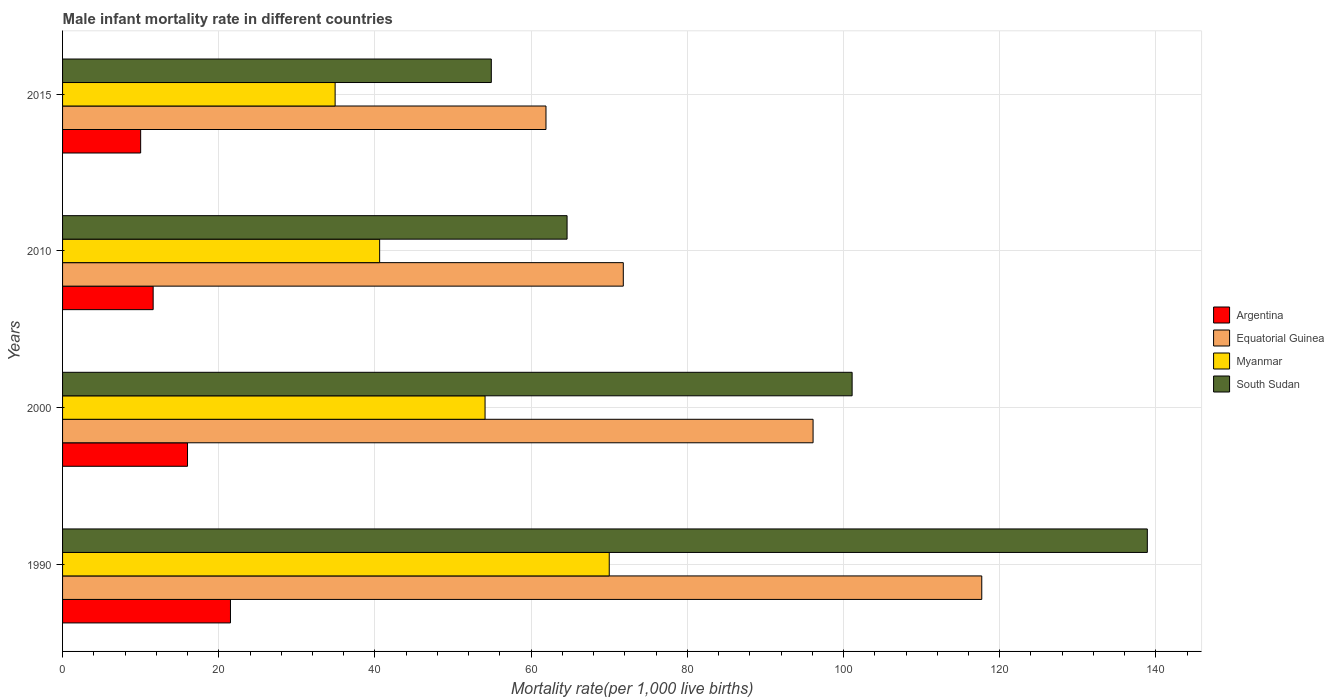Are the number of bars on each tick of the Y-axis equal?
Keep it short and to the point. Yes. What is the label of the 4th group of bars from the top?
Keep it short and to the point. 1990. What is the male infant mortality rate in Argentina in 1990?
Ensure brevity in your answer.  21.5. Across all years, what is the maximum male infant mortality rate in Equatorial Guinea?
Your answer should be very brief. 117.7. Across all years, what is the minimum male infant mortality rate in Argentina?
Provide a short and direct response. 10. In which year was the male infant mortality rate in Argentina maximum?
Provide a short and direct response. 1990. In which year was the male infant mortality rate in South Sudan minimum?
Your answer should be compact. 2015. What is the total male infant mortality rate in Myanmar in the graph?
Make the answer very short. 199.6. What is the difference between the male infant mortality rate in Myanmar in 1990 and that in 2000?
Make the answer very short. 15.9. What is the difference between the male infant mortality rate in Argentina in 2010 and the male infant mortality rate in Equatorial Guinea in 2015?
Ensure brevity in your answer.  -50.3. What is the average male infant mortality rate in Equatorial Guinea per year?
Make the answer very short. 86.88. In the year 2015, what is the difference between the male infant mortality rate in South Sudan and male infant mortality rate in Argentina?
Make the answer very short. 44.9. In how many years, is the male infant mortality rate in South Sudan greater than 100 ?
Your response must be concise. 2. What is the ratio of the male infant mortality rate in South Sudan in 2000 to that in 2015?
Ensure brevity in your answer.  1.84. Is the difference between the male infant mortality rate in South Sudan in 1990 and 2015 greater than the difference between the male infant mortality rate in Argentina in 1990 and 2015?
Offer a terse response. Yes. What is the difference between the highest and the second highest male infant mortality rate in Myanmar?
Make the answer very short. 15.9. Is the sum of the male infant mortality rate in Argentina in 2010 and 2015 greater than the maximum male infant mortality rate in South Sudan across all years?
Offer a very short reply. No. What does the 4th bar from the top in 2015 represents?
Keep it short and to the point. Argentina. Is it the case that in every year, the sum of the male infant mortality rate in South Sudan and male infant mortality rate in Equatorial Guinea is greater than the male infant mortality rate in Argentina?
Your answer should be very brief. Yes. Are the values on the major ticks of X-axis written in scientific E-notation?
Give a very brief answer. No. How many legend labels are there?
Offer a terse response. 4. How are the legend labels stacked?
Your answer should be compact. Vertical. What is the title of the graph?
Offer a very short reply. Male infant mortality rate in different countries. Does "St. Lucia" appear as one of the legend labels in the graph?
Your response must be concise. No. What is the label or title of the X-axis?
Your response must be concise. Mortality rate(per 1,0 live births). What is the label or title of the Y-axis?
Your answer should be compact. Years. What is the Mortality rate(per 1,000 live births) in Equatorial Guinea in 1990?
Keep it short and to the point. 117.7. What is the Mortality rate(per 1,000 live births) of Myanmar in 1990?
Offer a very short reply. 70. What is the Mortality rate(per 1,000 live births) of South Sudan in 1990?
Your response must be concise. 138.9. What is the Mortality rate(per 1,000 live births) in Equatorial Guinea in 2000?
Provide a succinct answer. 96.1. What is the Mortality rate(per 1,000 live births) in Myanmar in 2000?
Provide a succinct answer. 54.1. What is the Mortality rate(per 1,000 live births) of South Sudan in 2000?
Ensure brevity in your answer.  101.1. What is the Mortality rate(per 1,000 live births) of Equatorial Guinea in 2010?
Your answer should be compact. 71.8. What is the Mortality rate(per 1,000 live births) of Myanmar in 2010?
Your answer should be compact. 40.6. What is the Mortality rate(per 1,000 live births) in South Sudan in 2010?
Give a very brief answer. 64.6. What is the Mortality rate(per 1,000 live births) in Equatorial Guinea in 2015?
Make the answer very short. 61.9. What is the Mortality rate(per 1,000 live births) in Myanmar in 2015?
Offer a very short reply. 34.9. What is the Mortality rate(per 1,000 live births) of South Sudan in 2015?
Offer a very short reply. 54.9. Across all years, what is the maximum Mortality rate(per 1,000 live births) of Equatorial Guinea?
Make the answer very short. 117.7. Across all years, what is the maximum Mortality rate(per 1,000 live births) in Myanmar?
Offer a very short reply. 70. Across all years, what is the maximum Mortality rate(per 1,000 live births) of South Sudan?
Offer a terse response. 138.9. Across all years, what is the minimum Mortality rate(per 1,000 live births) of Argentina?
Give a very brief answer. 10. Across all years, what is the minimum Mortality rate(per 1,000 live births) in Equatorial Guinea?
Provide a short and direct response. 61.9. Across all years, what is the minimum Mortality rate(per 1,000 live births) in Myanmar?
Your answer should be compact. 34.9. Across all years, what is the minimum Mortality rate(per 1,000 live births) in South Sudan?
Make the answer very short. 54.9. What is the total Mortality rate(per 1,000 live births) of Argentina in the graph?
Keep it short and to the point. 59.1. What is the total Mortality rate(per 1,000 live births) in Equatorial Guinea in the graph?
Keep it short and to the point. 347.5. What is the total Mortality rate(per 1,000 live births) of Myanmar in the graph?
Your answer should be compact. 199.6. What is the total Mortality rate(per 1,000 live births) of South Sudan in the graph?
Ensure brevity in your answer.  359.5. What is the difference between the Mortality rate(per 1,000 live births) in Equatorial Guinea in 1990 and that in 2000?
Your answer should be compact. 21.6. What is the difference between the Mortality rate(per 1,000 live births) in South Sudan in 1990 and that in 2000?
Offer a terse response. 37.8. What is the difference between the Mortality rate(per 1,000 live births) in Argentina in 1990 and that in 2010?
Give a very brief answer. 9.9. What is the difference between the Mortality rate(per 1,000 live births) of Equatorial Guinea in 1990 and that in 2010?
Make the answer very short. 45.9. What is the difference between the Mortality rate(per 1,000 live births) in Myanmar in 1990 and that in 2010?
Make the answer very short. 29.4. What is the difference between the Mortality rate(per 1,000 live births) in South Sudan in 1990 and that in 2010?
Give a very brief answer. 74.3. What is the difference between the Mortality rate(per 1,000 live births) in Argentina in 1990 and that in 2015?
Your response must be concise. 11.5. What is the difference between the Mortality rate(per 1,000 live births) of Equatorial Guinea in 1990 and that in 2015?
Give a very brief answer. 55.8. What is the difference between the Mortality rate(per 1,000 live births) of Myanmar in 1990 and that in 2015?
Give a very brief answer. 35.1. What is the difference between the Mortality rate(per 1,000 live births) in Argentina in 2000 and that in 2010?
Your answer should be very brief. 4.4. What is the difference between the Mortality rate(per 1,000 live births) in Equatorial Guinea in 2000 and that in 2010?
Your answer should be very brief. 24.3. What is the difference between the Mortality rate(per 1,000 live births) in Myanmar in 2000 and that in 2010?
Give a very brief answer. 13.5. What is the difference between the Mortality rate(per 1,000 live births) in South Sudan in 2000 and that in 2010?
Ensure brevity in your answer.  36.5. What is the difference between the Mortality rate(per 1,000 live births) in Argentina in 2000 and that in 2015?
Offer a terse response. 6. What is the difference between the Mortality rate(per 1,000 live births) in Equatorial Guinea in 2000 and that in 2015?
Make the answer very short. 34.2. What is the difference between the Mortality rate(per 1,000 live births) in South Sudan in 2000 and that in 2015?
Your answer should be very brief. 46.2. What is the difference between the Mortality rate(per 1,000 live births) in Equatorial Guinea in 2010 and that in 2015?
Provide a short and direct response. 9.9. What is the difference between the Mortality rate(per 1,000 live births) in Myanmar in 2010 and that in 2015?
Offer a terse response. 5.7. What is the difference between the Mortality rate(per 1,000 live births) in Argentina in 1990 and the Mortality rate(per 1,000 live births) in Equatorial Guinea in 2000?
Provide a succinct answer. -74.6. What is the difference between the Mortality rate(per 1,000 live births) of Argentina in 1990 and the Mortality rate(per 1,000 live births) of Myanmar in 2000?
Your answer should be very brief. -32.6. What is the difference between the Mortality rate(per 1,000 live births) in Argentina in 1990 and the Mortality rate(per 1,000 live births) in South Sudan in 2000?
Offer a very short reply. -79.6. What is the difference between the Mortality rate(per 1,000 live births) of Equatorial Guinea in 1990 and the Mortality rate(per 1,000 live births) of Myanmar in 2000?
Your answer should be compact. 63.6. What is the difference between the Mortality rate(per 1,000 live births) of Equatorial Guinea in 1990 and the Mortality rate(per 1,000 live births) of South Sudan in 2000?
Keep it short and to the point. 16.6. What is the difference between the Mortality rate(per 1,000 live births) of Myanmar in 1990 and the Mortality rate(per 1,000 live births) of South Sudan in 2000?
Offer a terse response. -31.1. What is the difference between the Mortality rate(per 1,000 live births) in Argentina in 1990 and the Mortality rate(per 1,000 live births) in Equatorial Guinea in 2010?
Offer a terse response. -50.3. What is the difference between the Mortality rate(per 1,000 live births) of Argentina in 1990 and the Mortality rate(per 1,000 live births) of Myanmar in 2010?
Your answer should be very brief. -19.1. What is the difference between the Mortality rate(per 1,000 live births) in Argentina in 1990 and the Mortality rate(per 1,000 live births) in South Sudan in 2010?
Your response must be concise. -43.1. What is the difference between the Mortality rate(per 1,000 live births) of Equatorial Guinea in 1990 and the Mortality rate(per 1,000 live births) of Myanmar in 2010?
Your answer should be very brief. 77.1. What is the difference between the Mortality rate(per 1,000 live births) in Equatorial Guinea in 1990 and the Mortality rate(per 1,000 live births) in South Sudan in 2010?
Offer a terse response. 53.1. What is the difference between the Mortality rate(per 1,000 live births) in Myanmar in 1990 and the Mortality rate(per 1,000 live births) in South Sudan in 2010?
Ensure brevity in your answer.  5.4. What is the difference between the Mortality rate(per 1,000 live births) of Argentina in 1990 and the Mortality rate(per 1,000 live births) of Equatorial Guinea in 2015?
Offer a very short reply. -40.4. What is the difference between the Mortality rate(per 1,000 live births) in Argentina in 1990 and the Mortality rate(per 1,000 live births) in Myanmar in 2015?
Your response must be concise. -13.4. What is the difference between the Mortality rate(per 1,000 live births) in Argentina in 1990 and the Mortality rate(per 1,000 live births) in South Sudan in 2015?
Your answer should be very brief. -33.4. What is the difference between the Mortality rate(per 1,000 live births) of Equatorial Guinea in 1990 and the Mortality rate(per 1,000 live births) of Myanmar in 2015?
Make the answer very short. 82.8. What is the difference between the Mortality rate(per 1,000 live births) in Equatorial Guinea in 1990 and the Mortality rate(per 1,000 live births) in South Sudan in 2015?
Offer a terse response. 62.8. What is the difference between the Mortality rate(per 1,000 live births) in Argentina in 2000 and the Mortality rate(per 1,000 live births) in Equatorial Guinea in 2010?
Provide a short and direct response. -55.8. What is the difference between the Mortality rate(per 1,000 live births) of Argentina in 2000 and the Mortality rate(per 1,000 live births) of Myanmar in 2010?
Offer a very short reply. -24.6. What is the difference between the Mortality rate(per 1,000 live births) of Argentina in 2000 and the Mortality rate(per 1,000 live births) of South Sudan in 2010?
Your answer should be very brief. -48.6. What is the difference between the Mortality rate(per 1,000 live births) of Equatorial Guinea in 2000 and the Mortality rate(per 1,000 live births) of Myanmar in 2010?
Ensure brevity in your answer.  55.5. What is the difference between the Mortality rate(per 1,000 live births) in Equatorial Guinea in 2000 and the Mortality rate(per 1,000 live births) in South Sudan in 2010?
Make the answer very short. 31.5. What is the difference between the Mortality rate(per 1,000 live births) of Myanmar in 2000 and the Mortality rate(per 1,000 live births) of South Sudan in 2010?
Your answer should be very brief. -10.5. What is the difference between the Mortality rate(per 1,000 live births) of Argentina in 2000 and the Mortality rate(per 1,000 live births) of Equatorial Guinea in 2015?
Make the answer very short. -45.9. What is the difference between the Mortality rate(per 1,000 live births) of Argentina in 2000 and the Mortality rate(per 1,000 live births) of Myanmar in 2015?
Give a very brief answer. -18.9. What is the difference between the Mortality rate(per 1,000 live births) in Argentina in 2000 and the Mortality rate(per 1,000 live births) in South Sudan in 2015?
Keep it short and to the point. -38.9. What is the difference between the Mortality rate(per 1,000 live births) in Equatorial Guinea in 2000 and the Mortality rate(per 1,000 live births) in Myanmar in 2015?
Your answer should be very brief. 61.2. What is the difference between the Mortality rate(per 1,000 live births) in Equatorial Guinea in 2000 and the Mortality rate(per 1,000 live births) in South Sudan in 2015?
Your answer should be compact. 41.2. What is the difference between the Mortality rate(per 1,000 live births) of Myanmar in 2000 and the Mortality rate(per 1,000 live births) of South Sudan in 2015?
Offer a very short reply. -0.8. What is the difference between the Mortality rate(per 1,000 live births) of Argentina in 2010 and the Mortality rate(per 1,000 live births) of Equatorial Guinea in 2015?
Make the answer very short. -50.3. What is the difference between the Mortality rate(per 1,000 live births) of Argentina in 2010 and the Mortality rate(per 1,000 live births) of Myanmar in 2015?
Provide a short and direct response. -23.3. What is the difference between the Mortality rate(per 1,000 live births) in Argentina in 2010 and the Mortality rate(per 1,000 live births) in South Sudan in 2015?
Keep it short and to the point. -43.3. What is the difference between the Mortality rate(per 1,000 live births) in Equatorial Guinea in 2010 and the Mortality rate(per 1,000 live births) in Myanmar in 2015?
Offer a terse response. 36.9. What is the difference between the Mortality rate(per 1,000 live births) of Equatorial Guinea in 2010 and the Mortality rate(per 1,000 live births) of South Sudan in 2015?
Your answer should be compact. 16.9. What is the difference between the Mortality rate(per 1,000 live births) of Myanmar in 2010 and the Mortality rate(per 1,000 live births) of South Sudan in 2015?
Keep it short and to the point. -14.3. What is the average Mortality rate(per 1,000 live births) in Argentina per year?
Ensure brevity in your answer.  14.78. What is the average Mortality rate(per 1,000 live births) in Equatorial Guinea per year?
Your response must be concise. 86.88. What is the average Mortality rate(per 1,000 live births) in Myanmar per year?
Offer a terse response. 49.9. What is the average Mortality rate(per 1,000 live births) of South Sudan per year?
Ensure brevity in your answer.  89.88. In the year 1990, what is the difference between the Mortality rate(per 1,000 live births) in Argentina and Mortality rate(per 1,000 live births) in Equatorial Guinea?
Your answer should be very brief. -96.2. In the year 1990, what is the difference between the Mortality rate(per 1,000 live births) of Argentina and Mortality rate(per 1,000 live births) of Myanmar?
Your response must be concise. -48.5. In the year 1990, what is the difference between the Mortality rate(per 1,000 live births) in Argentina and Mortality rate(per 1,000 live births) in South Sudan?
Offer a terse response. -117.4. In the year 1990, what is the difference between the Mortality rate(per 1,000 live births) in Equatorial Guinea and Mortality rate(per 1,000 live births) in Myanmar?
Your answer should be very brief. 47.7. In the year 1990, what is the difference between the Mortality rate(per 1,000 live births) of Equatorial Guinea and Mortality rate(per 1,000 live births) of South Sudan?
Your response must be concise. -21.2. In the year 1990, what is the difference between the Mortality rate(per 1,000 live births) of Myanmar and Mortality rate(per 1,000 live births) of South Sudan?
Your answer should be very brief. -68.9. In the year 2000, what is the difference between the Mortality rate(per 1,000 live births) of Argentina and Mortality rate(per 1,000 live births) of Equatorial Guinea?
Provide a short and direct response. -80.1. In the year 2000, what is the difference between the Mortality rate(per 1,000 live births) of Argentina and Mortality rate(per 1,000 live births) of Myanmar?
Offer a terse response. -38.1. In the year 2000, what is the difference between the Mortality rate(per 1,000 live births) in Argentina and Mortality rate(per 1,000 live births) in South Sudan?
Provide a succinct answer. -85.1. In the year 2000, what is the difference between the Mortality rate(per 1,000 live births) in Equatorial Guinea and Mortality rate(per 1,000 live births) in South Sudan?
Provide a succinct answer. -5. In the year 2000, what is the difference between the Mortality rate(per 1,000 live births) of Myanmar and Mortality rate(per 1,000 live births) of South Sudan?
Make the answer very short. -47. In the year 2010, what is the difference between the Mortality rate(per 1,000 live births) of Argentina and Mortality rate(per 1,000 live births) of Equatorial Guinea?
Provide a succinct answer. -60.2. In the year 2010, what is the difference between the Mortality rate(per 1,000 live births) in Argentina and Mortality rate(per 1,000 live births) in Myanmar?
Give a very brief answer. -29. In the year 2010, what is the difference between the Mortality rate(per 1,000 live births) of Argentina and Mortality rate(per 1,000 live births) of South Sudan?
Provide a succinct answer. -53. In the year 2010, what is the difference between the Mortality rate(per 1,000 live births) in Equatorial Guinea and Mortality rate(per 1,000 live births) in Myanmar?
Ensure brevity in your answer.  31.2. In the year 2015, what is the difference between the Mortality rate(per 1,000 live births) in Argentina and Mortality rate(per 1,000 live births) in Equatorial Guinea?
Ensure brevity in your answer.  -51.9. In the year 2015, what is the difference between the Mortality rate(per 1,000 live births) in Argentina and Mortality rate(per 1,000 live births) in Myanmar?
Provide a succinct answer. -24.9. In the year 2015, what is the difference between the Mortality rate(per 1,000 live births) in Argentina and Mortality rate(per 1,000 live births) in South Sudan?
Provide a succinct answer. -44.9. In the year 2015, what is the difference between the Mortality rate(per 1,000 live births) in Equatorial Guinea and Mortality rate(per 1,000 live births) in Myanmar?
Provide a short and direct response. 27. In the year 2015, what is the difference between the Mortality rate(per 1,000 live births) in Equatorial Guinea and Mortality rate(per 1,000 live births) in South Sudan?
Offer a very short reply. 7. What is the ratio of the Mortality rate(per 1,000 live births) of Argentina in 1990 to that in 2000?
Offer a terse response. 1.34. What is the ratio of the Mortality rate(per 1,000 live births) in Equatorial Guinea in 1990 to that in 2000?
Provide a succinct answer. 1.22. What is the ratio of the Mortality rate(per 1,000 live births) in Myanmar in 1990 to that in 2000?
Provide a short and direct response. 1.29. What is the ratio of the Mortality rate(per 1,000 live births) in South Sudan in 1990 to that in 2000?
Provide a short and direct response. 1.37. What is the ratio of the Mortality rate(per 1,000 live births) in Argentina in 1990 to that in 2010?
Offer a terse response. 1.85. What is the ratio of the Mortality rate(per 1,000 live births) in Equatorial Guinea in 1990 to that in 2010?
Your response must be concise. 1.64. What is the ratio of the Mortality rate(per 1,000 live births) in Myanmar in 1990 to that in 2010?
Provide a succinct answer. 1.72. What is the ratio of the Mortality rate(per 1,000 live births) in South Sudan in 1990 to that in 2010?
Your answer should be very brief. 2.15. What is the ratio of the Mortality rate(per 1,000 live births) of Argentina in 1990 to that in 2015?
Your response must be concise. 2.15. What is the ratio of the Mortality rate(per 1,000 live births) of Equatorial Guinea in 1990 to that in 2015?
Your response must be concise. 1.9. What is the ratio of the Mortality rate(per 1,000 live births) of Myanmar in 1990 to that in 2015?
Ensure brevity in your answer.  2.01. What is the ratio of the Mortality rate(per 1,000 live births) in South Sudan in 1990 to that in 2015?
Provide a short and direct response. 2.53. What is the ratio of the Mortality rate(per 1,000 live births) in Argentina in 2000 to that in 2010?
Give a very brief answer. 1.38. What is the ratio of the Mortality rate(per 1,000 live births) of Equatorial Guinea in 2000 to that in 2010?
Offer a terse response. 1.34. What is the ratio of the Mortality rate(per 1,000 live births) in Myanmar in 2000 to that in 2010?
Give a very brief answer. 1.33. What is the ratio of the Mortality rate(per 1,000 live births) of South Sudan in 2000 to that in 2010?
Your answer should be compact. 1.56. What is the ratio of the Mortality rate(per 1,000 live births) in Argentina in 2000 to that in 2015?
Give a very brief answer. 1.6. What is the ratio of the Mortality rate(per 1,000 live births) in Equatorial Guinea in 2000 to that in 2015?
Provide a short and direct response. 1.55. What is the ratio of the Mortality rate(per 1,000 live births) of Myanmar in 2000 to that in 2015?
Your response must be concise. 1.55. What is the ratio of the Mortality rate(per 1,000 live births) in South Sudan in 2000 to that in 2015?
Ensure brevity in your answer.  1.84. What is the ratio of the Mortality rate(per 1,000 live births) of Argentina in 2010 to that in 2015?
Give a very brief answer. 1.16. What is the ratio of the Mortality rate(per 1,000 live births) of Equatorial Guinea in 2010 to that in 2015?
Make the answer very short. 1.16. What is the ratio of the Mortality rate(per 1,000 live births) in Myanmar in 2010 to that in 2015?
Make the answer very short. 1.16. What is the ratio of the Mortality rate(per 1,000 live births) of South Sudan in 2010 to that in 2015?
Your answer should be very brief. 1.18. What is the difference between the highest and the second highest Mortality rate(per 1,000 live births) of Argentina?
Offer a terse response. 5.5. What is the difference between the highest and the second highest Mortality rate(per 1,000 live births) of Equatorial Guinea?
Your answer should be very brief. 21.6. What is the difference between the highest and the second highest Mortality rate(per 1,000 live births) of Myanmar?
Provide a short and direct response. 15.9. What is the difference between the highest and the second highest Mortality rate(per 1,000 live births) in South Sudan?
Give a very brief answer. 37.8. What is the difference between the highest and the lowest Mortality rate(per 1,000 live births) of Equatorial Guinea?
Keep it short and to the point. 55.8. What is the difference between the highest and the lowest Mortality rate(per 1,000 live births) in Myanmar?
Make the answer very short. 35.1. What is the difference between the highest and the lowest Mortality rate(per 1,000 live births) of South Sudan?
Offer a terse response. 84. 